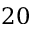Convert formula to latex. <formula><loc_0><loc_0><loc_500><loc_500>2 0</formula> 